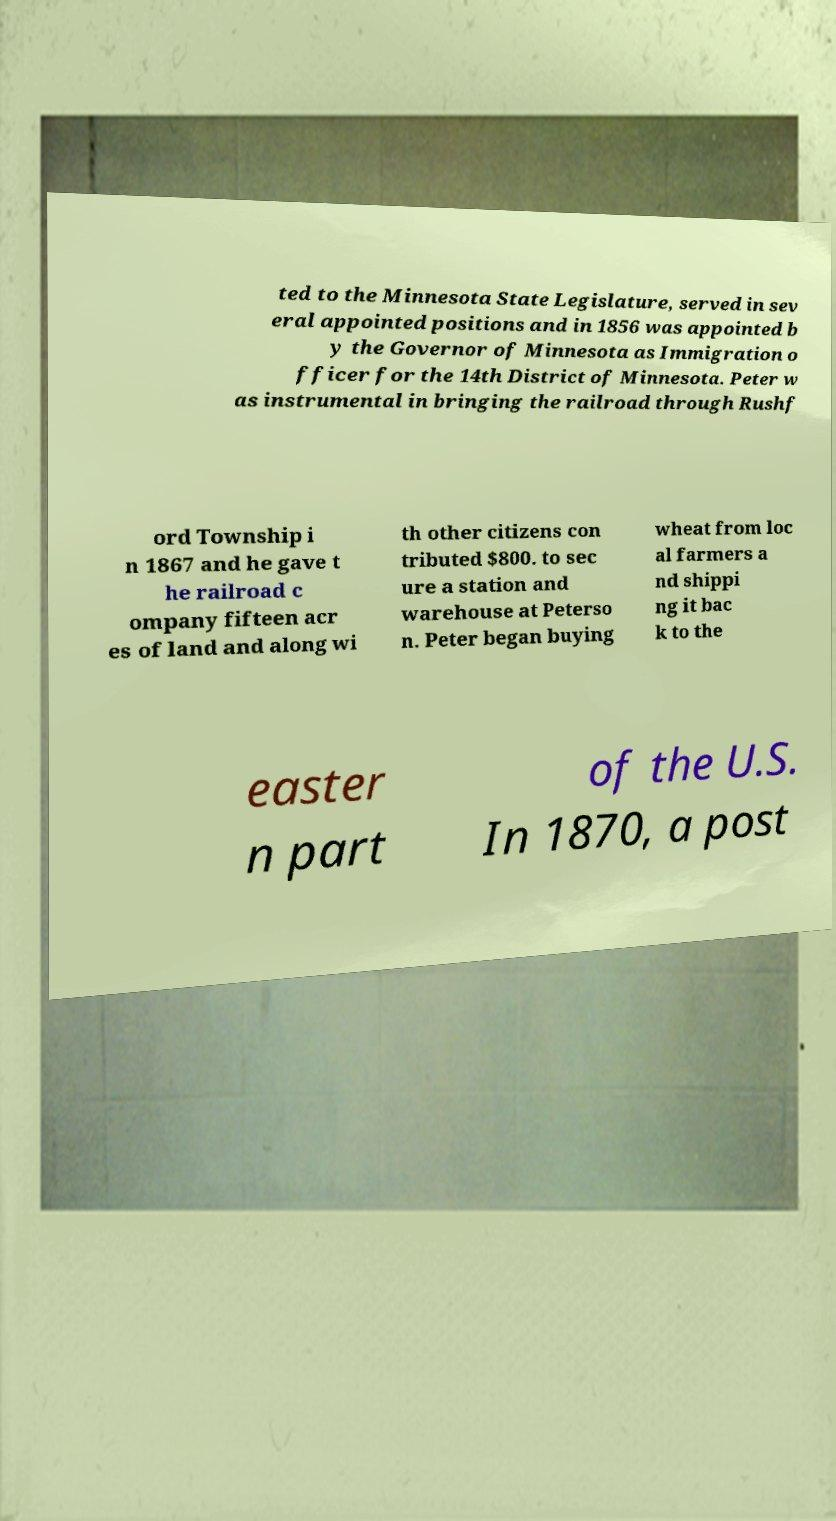Could you extract and type out the text from this image? ted to the Minnesota State Legislature, served in sev eral appointed positions and in 1856 was appointed b y the Governor of Minnesota as Immigration o fficer for the 14th District of Minnesota. Peter w as instrumental in bringing the railroad through Rushf ord Township i n 1867 and he gave t he railroad c ompany fifteen acr es of land and along wi th other citizens con tributed $800. to sec ure a station and warehouse at Peterso n. Peter began buying wheat from loc al farmers a nd shippi ng it bac k to the easter n part of the U.S. In 1870, a post 